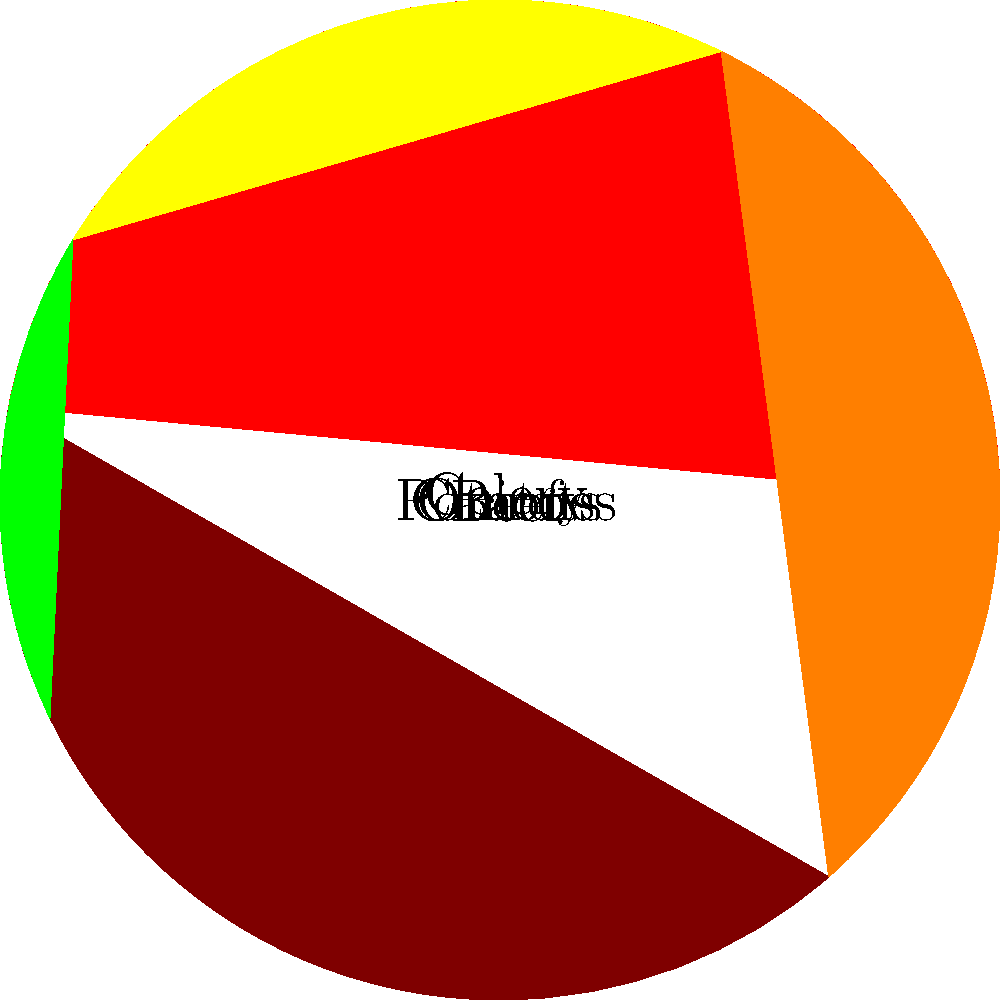You're developing a new beef stew recipe for your pub menu. The pie chart shows the proportions of key ingredients. If you're making a large batch that requires 6 kg of beef, how many kilograms of potatoes should you use to maintain the correct proportions? To solve this problem, we need to follow these steps:

1. Identify the proportions from the pie chart:
   Beef: 30%
   Potatoes: 15%

2. Set up a proportion equation:
   $\frac{\text{Beef}}{\text{Potatoes}} = \frac{30}{15} = 2$

3. We know the amount of beef is 6 kg, so we can set up the equation:
   $\frac{6 \text{ kg}}{\text{Potatoes}} = 2$

4. Solve for potatoes:
   $\text{Potatoes} = \frac{6 \text{ kg}}{2} = 3 \text{ kg}$

Therefore, to maintain the correct proportions, you should use 3 kg of potatoes when using 6 kg of beef.
Answer: 3 kg 